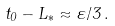<formula> <loc_0><loc_0><loc_500><loc_500>t _ { 0 } - L _ { * } \approx \varepsilon / 3 \, .</formula> 